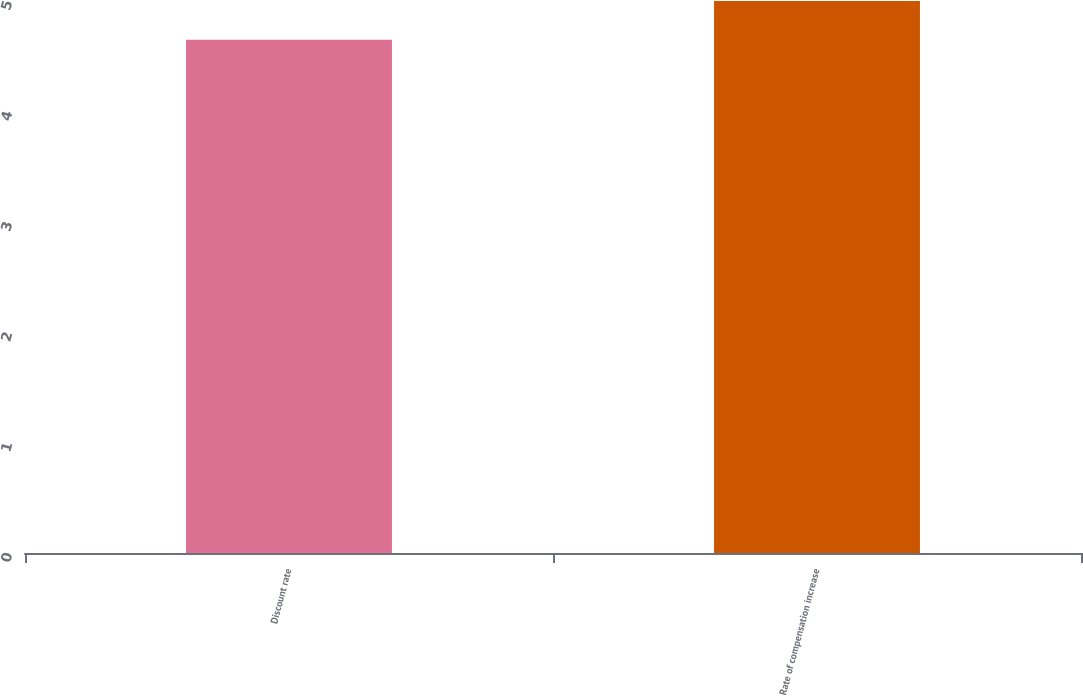<chart> <loc_0><loc_0><loc_500><loc_500><bar_chart><fcel>Discount rate<fcel>Rate of compensation increase<nl><fcel>4.65<fcel>5<nl></chart> 